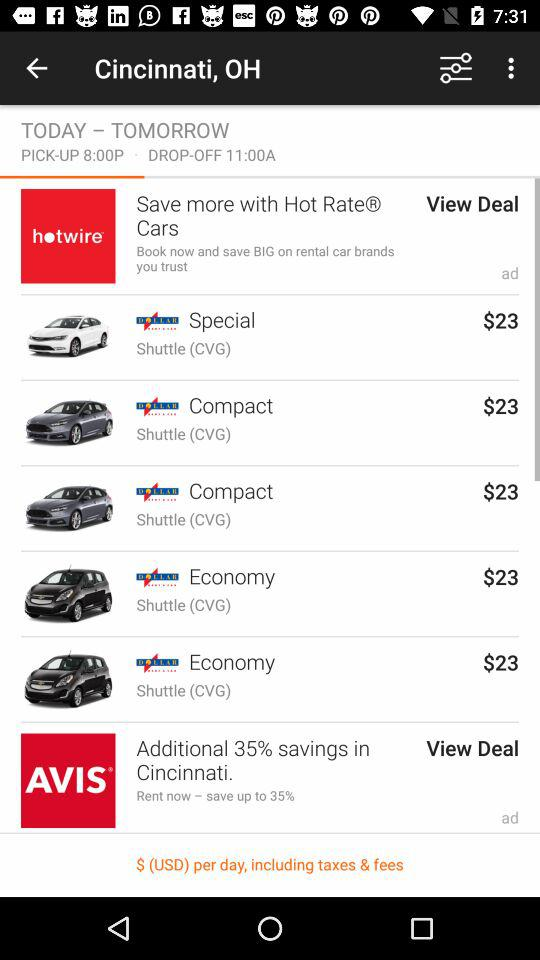What is the fare for the economy class? The fare for the economy class is $23. 